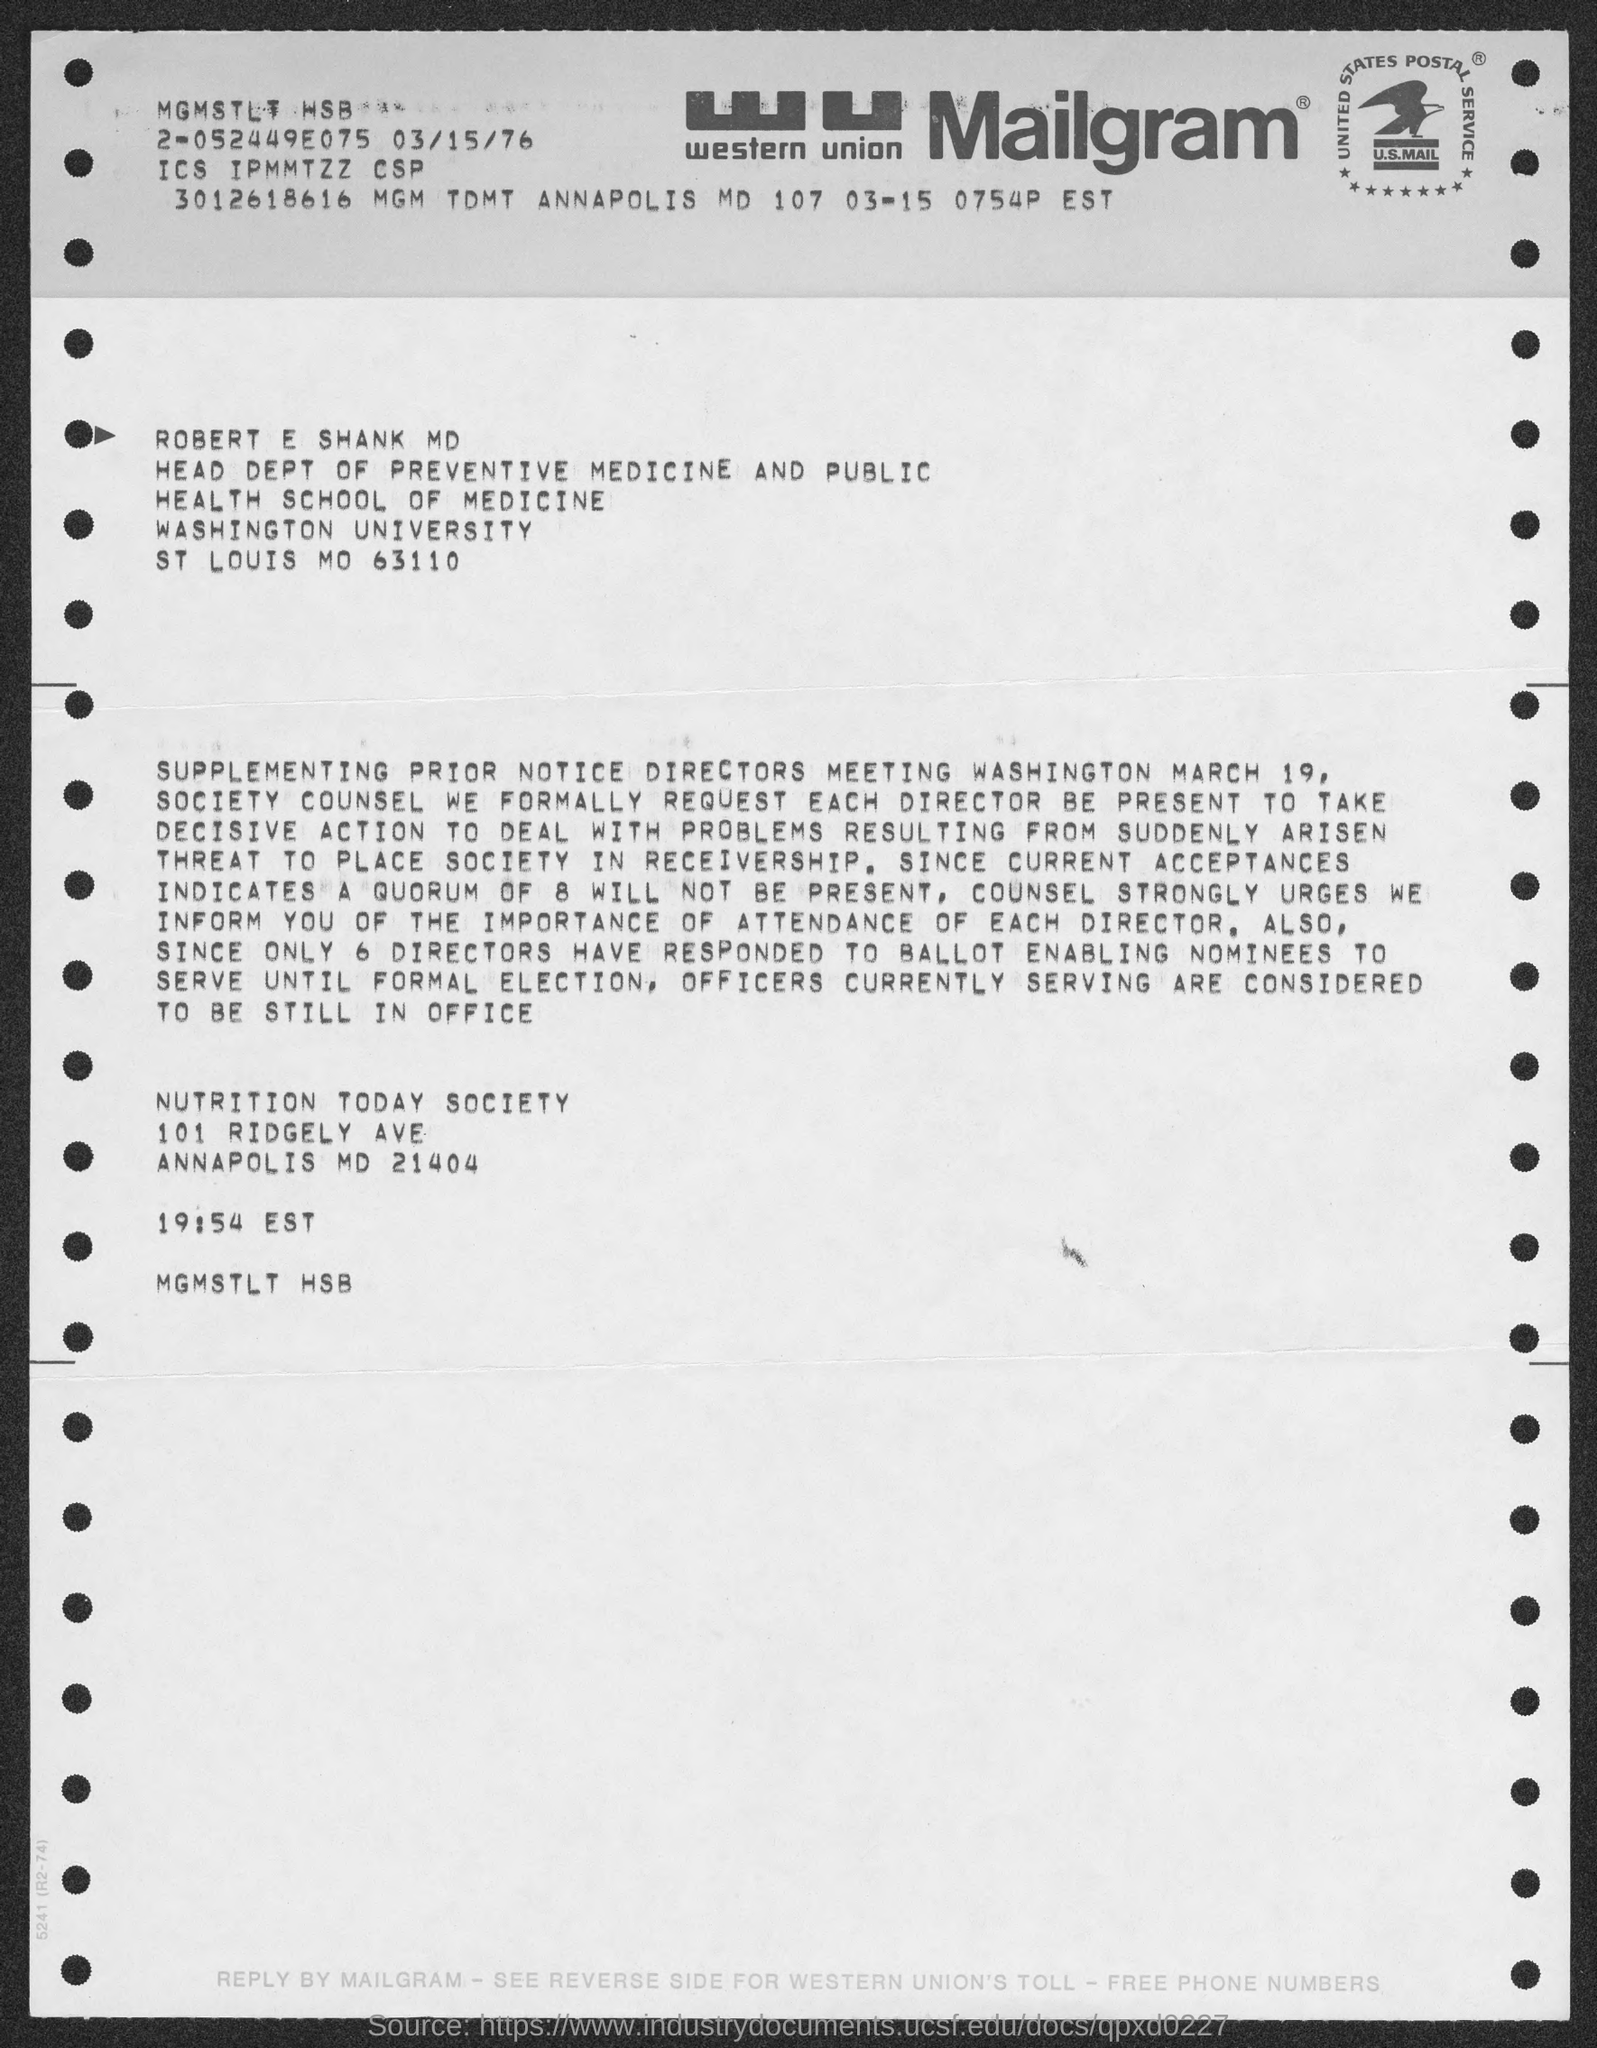What kind of communication is this ?
Give a very brief answer. Mailgram. Who is the Head of Dept of Preventive Medicine and Public Health?
Your response must be concise. Robert E Shank MD. 